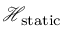<formula> <loc_0><loc_0><loc_500><loc_500>\mathcal { H } _ { s t a t i c }</formula> 